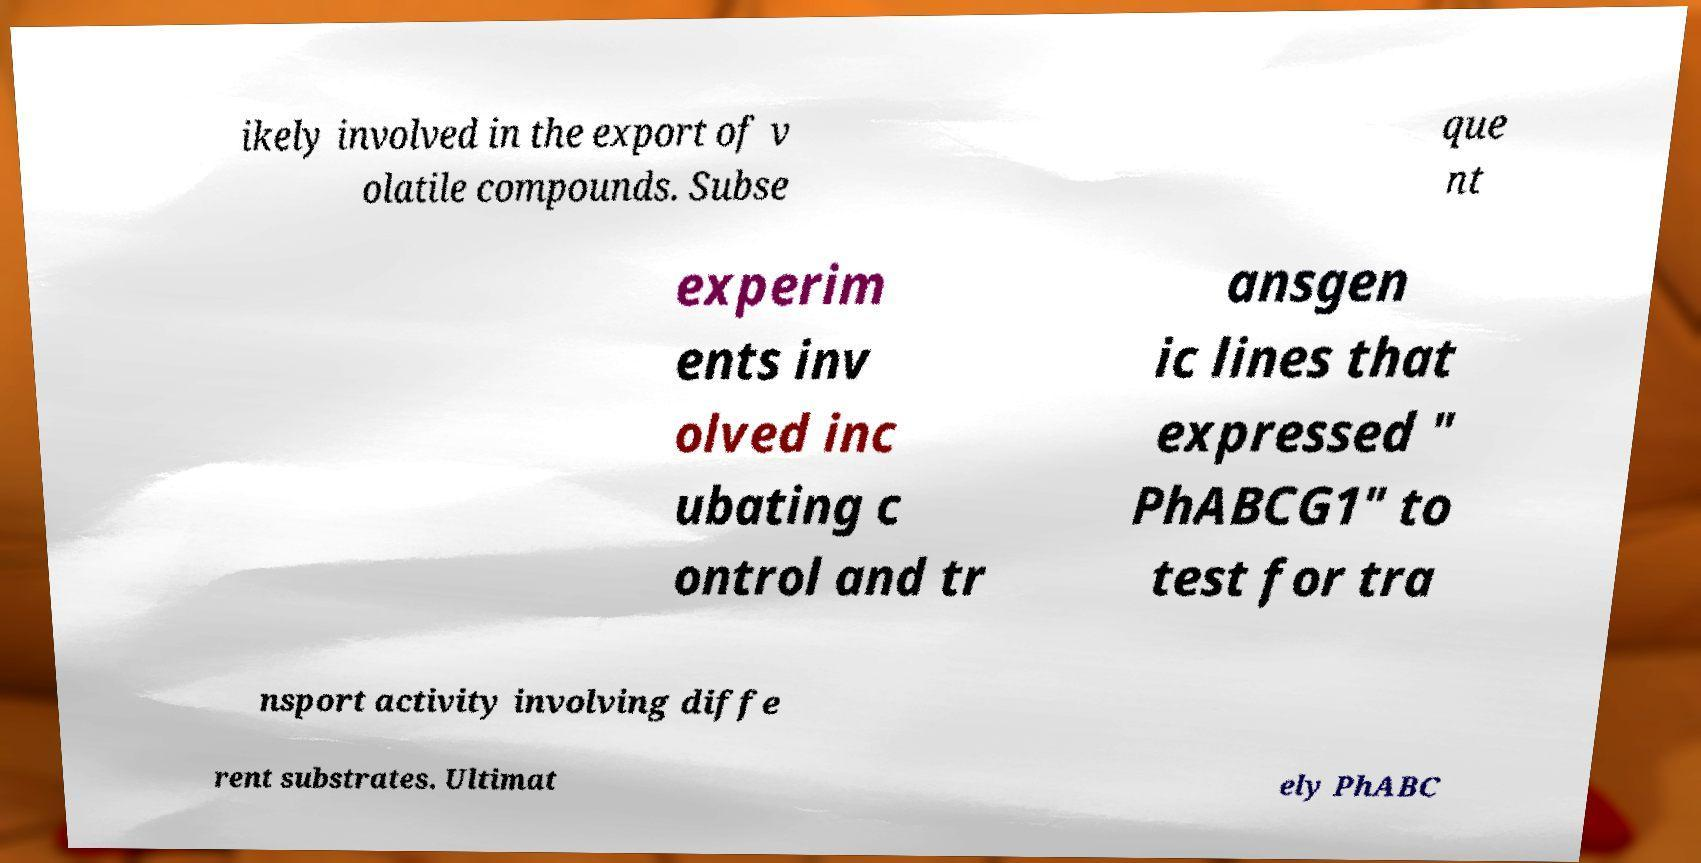I need the written content from this picture converted into text. Can you do that? ikely involved in the export of v olatile compounds. Subse que nt experim ents inv olved inc ubating c ontrol and tr ansgen ic lines that expressed " PhABCG1" to test for tra nsport activity involving diffe rent substrates. Ultimat ely PhABC 